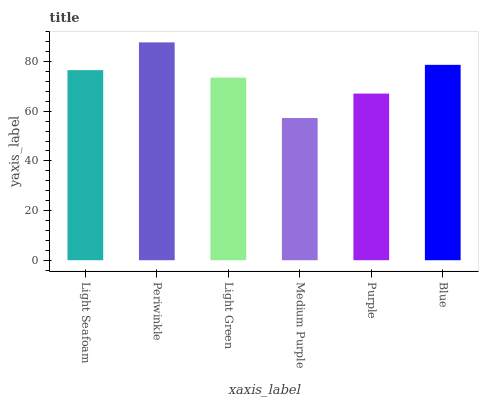Is Light Green the minimum?
Answer yes or no. No. Is Light Green the maximum?
Answer yes or no. No. Is Periwinkle greater than Light Green?
Answer yes or no. Yes. Is Light Green less than Periwinkle?
Answer yes or no. Yes. Is Light Green greater than Periwinkle?
Answer yes or no. No. Is Periwinkle less than Light Green?
Answer yes or no. No. Is Light Seafoam the high median?
Answer yes or no. Yes. Is Light Green the low median?
Answer yes or no. Yes. Is Purple the high median?
Answer yes or no. No. Is Blue the low median?
Answer yes or no. No. 